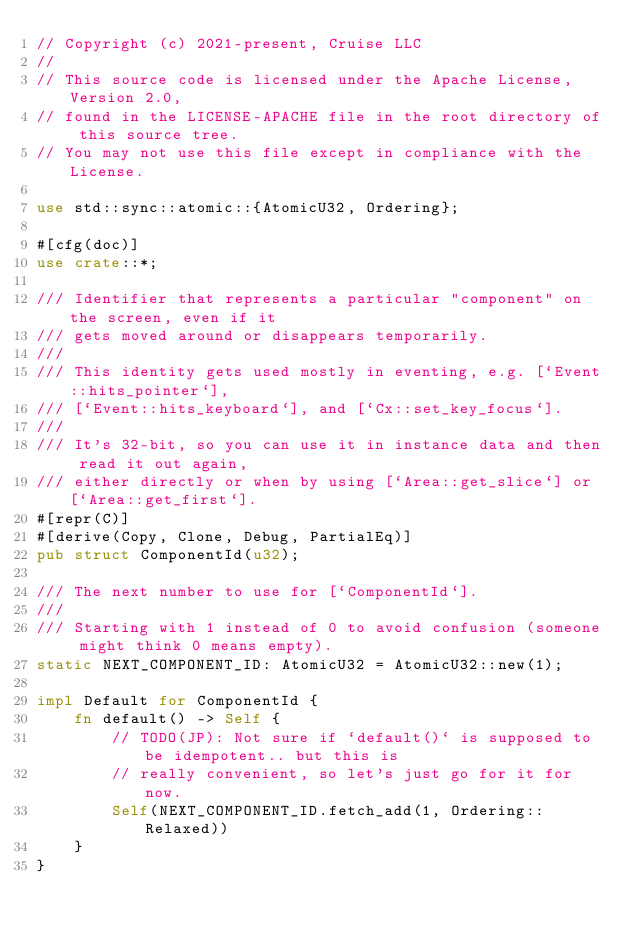Convert code to text. <code><loc_0><loc_0><loc_500><loc_500><_Rust_>// Copyright (c) 2021-present, Cruise LLC
//
// This source code is licensed under the Apache License, Version 2.0,
// found in the LICENSE-APACHE file in the root directory of this source tree.
// You may not use this file except in compliance with the License.

use std::sync::atomic::{AtomicU32, Ordering};

#[cfg(doc)]
use crate::*;

/// Identifier that represents a particular "component" on the screen, even if it
/// gets moved around or disappears temporarily.
///
/// This identity gets used mostly in eventing, e.g. [`Event::hits_pointer`],
/// [`Event::hits_keyboard`], and [`Cx::set_key_focus`].
///
/// It's 32-bit, so you can use it in instance data and then read it out again,
/// either directly or when by using [`Area::get_slice`] or [`Area::get_first`].
#[repr(C)]
#[derive(Copy, Clone, Debug, PartialEq)]
pub struct ComponentId(u32);

/// The next number to use for [`ComponentId`].
///
/// Starting with 1 instead of 0 to avoid confusion (someone might think 0 means empty).
static NEXT_COMPONENT_ID: AtomicU32 = AtomicU32::new(1);

impl Default for ComponentId {
    fn default() -> Self {
        // TODO(JP): Not sure if `default()` is supposed to be idempotent.. but this is
        // really convenient, so let's just go for it for now.
        Self(NEXT_COMPONENT_ID.fetch_add(1, Ordering::Relaxed))
    }
}
</code> 